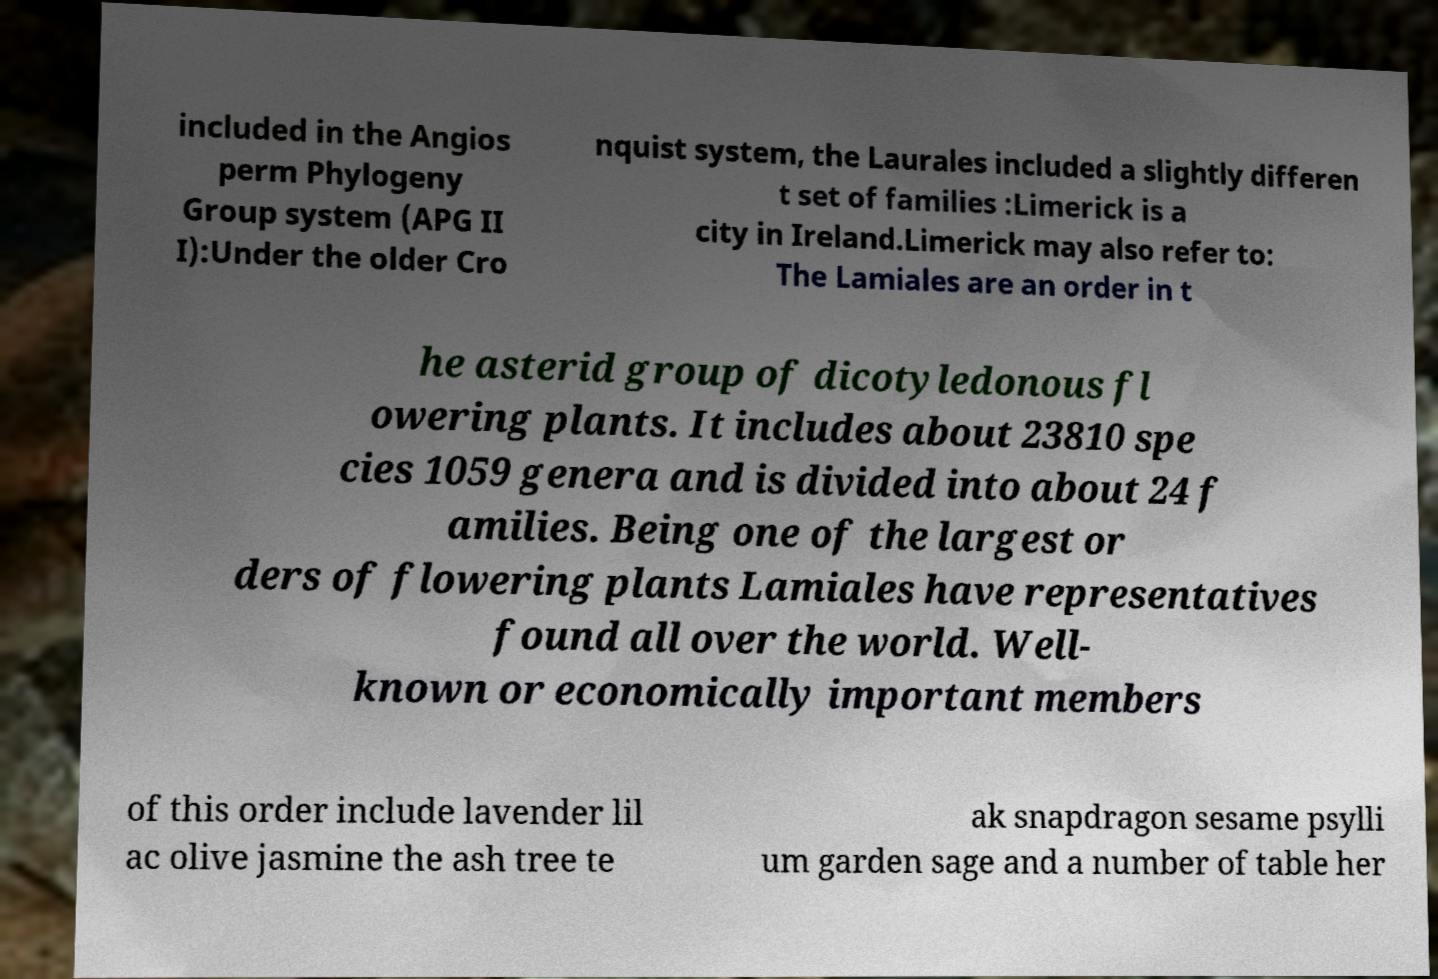Could you extract and type out the text from this image? included in the Angios perm Phylogeny Group system (APG II I):Under the older Cro nquist system, the Laurales included a slightly differen t set of families :Limerick is a city in Ireland.Limerick may also refer to: The Lamiales are an order in t he asterid group of dicotyledonous fl owering plants. It includes about 23810 spe cies 1059 genera and is divided into about 24 f amilies. Being one of the largest or ders of flowering plants Lamiales have representatives found all over the world. Well- known or economically important members of this order include lavender lil ac olive jasmine the ash tree te ak snapdragon sesame psylli um garden sage and a number of table her 